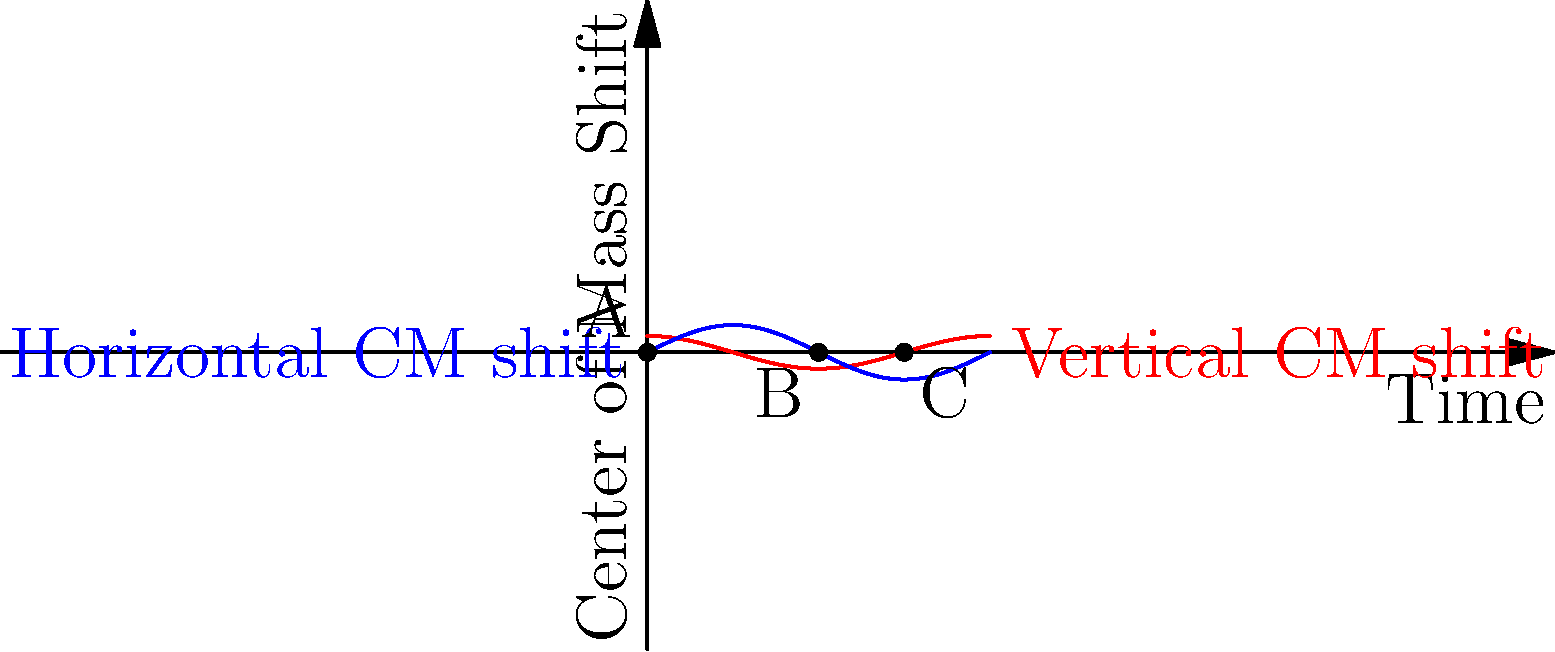In a space station, an astronaut performs a series of movements over time, causing shifts in their center of mass (CM). The graph shows the vertical (red) and horizontal (blue) CM shifts over time. At which point (A, B, or C) does the astronaut experience the maximum combined CM shift, and what does this imply about their body position? To determine the maximum combined CM shift and its implications, let's analyze the graph step-by-step:

1. Point A (0,0): This represents the initial position with no CM shift.

2. Point B (π, g(π)): 
   - Vertical shift: g(π) = 0.5 * sin(π) = 0
   - Horizontal shift: f(π) = 0.3 * cos(π) = -0.3

3. Point C (3π/2, f(3π/2)):
   - Vertical shift: g(3π/2) = 0.5 * sin(3π/2) = -0.5
   - Horizontal shift: f(3π/2) = 0.3 * cos(3π/2) ≈ 0

4. Calculate the combined CM shift using the Pythagorean theorem:
   - Point B: $\sqrt{0^2 + (-0.3)^2} = 0.3$
   - Point C: $\sqrt{(-0.5)^2 + 0^2} = 0.5$

5. The maximum combined CM shift occurs at Point C (0.5 > 0.3).

6. This implies that at Point C, the astronaut's body is maximally displaced vertically downward relative to their initial position, with minimal horizontal displacement.

In a space environment, this could represent:
- A crouching or bending motion
- Reaching for something below their initial position
- The end of a vertical jumping motion

The lack of horizontal shift suggests the movement is primarily in the vertical plane.
Answer: Point C; maximum vertical displacement, minimal horizontal shift. 